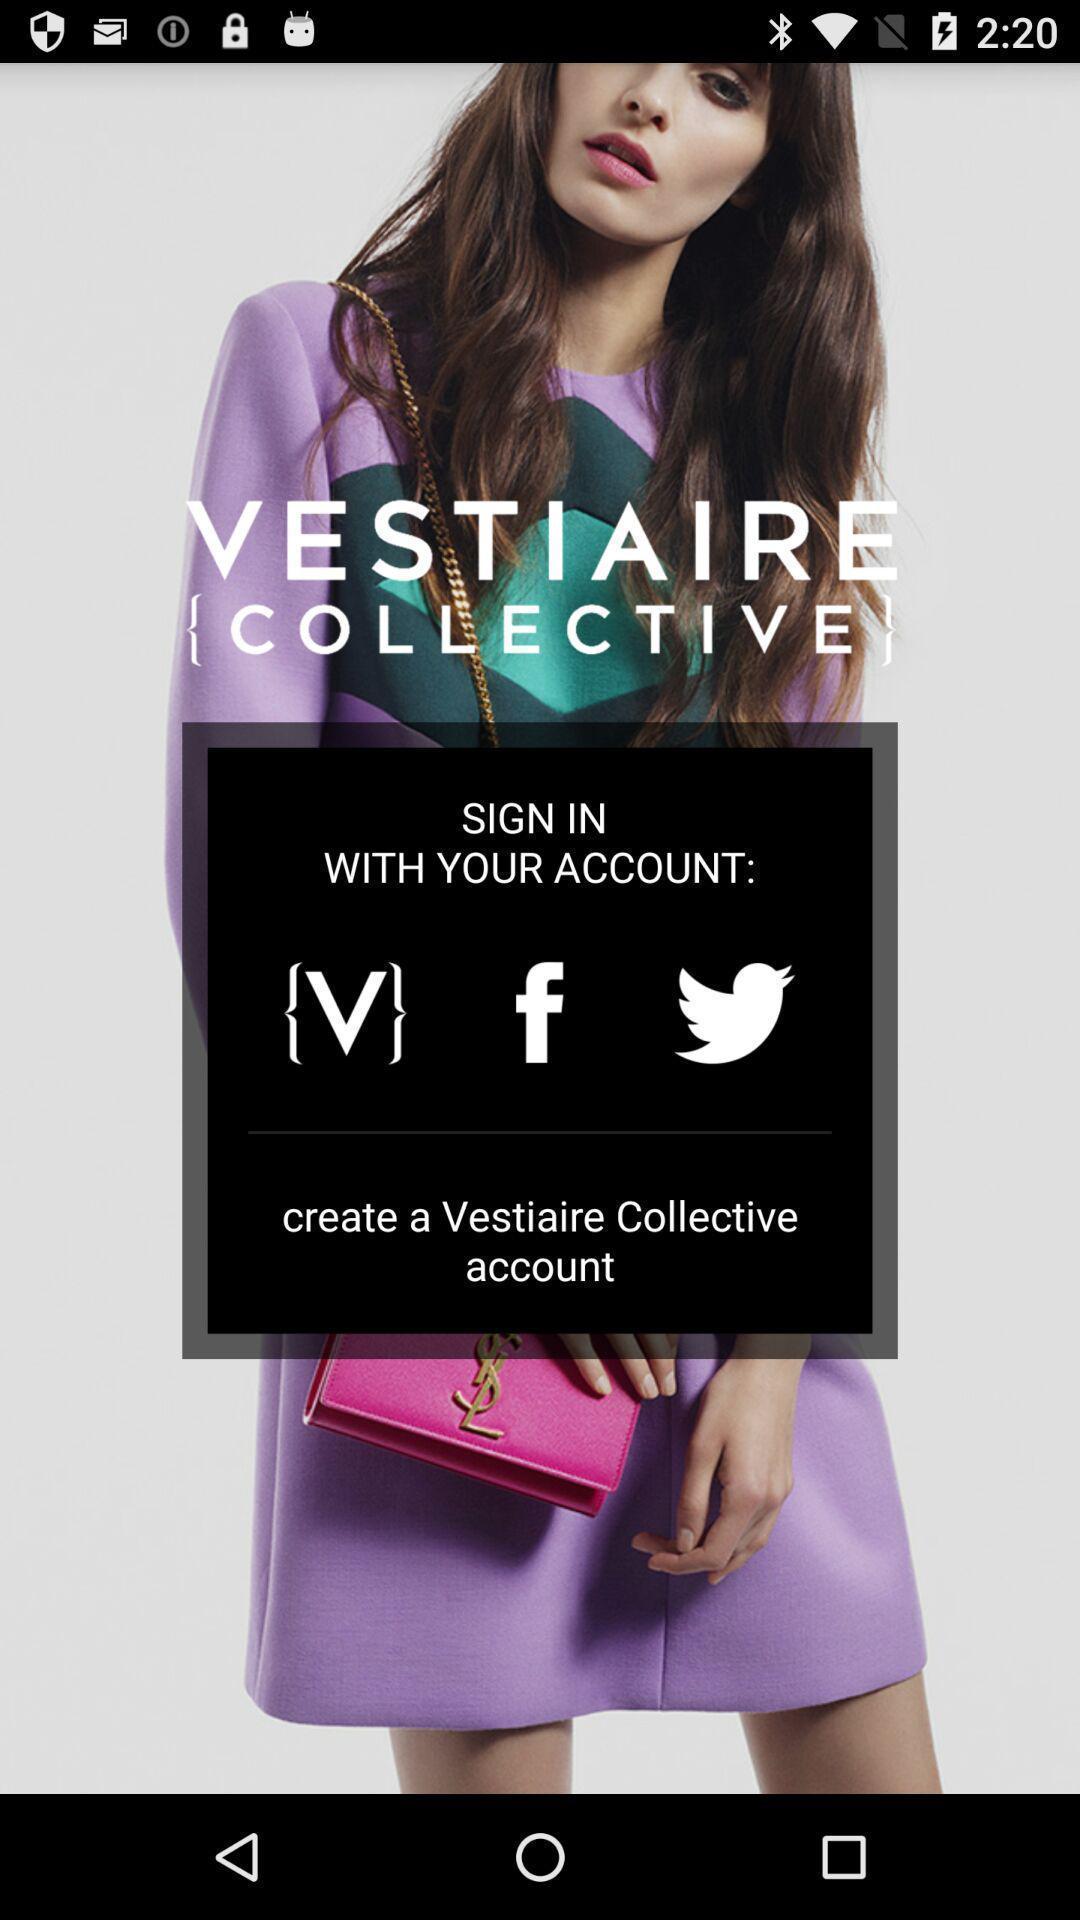Tell me what you see in this picture. Welcome page of a social application. 